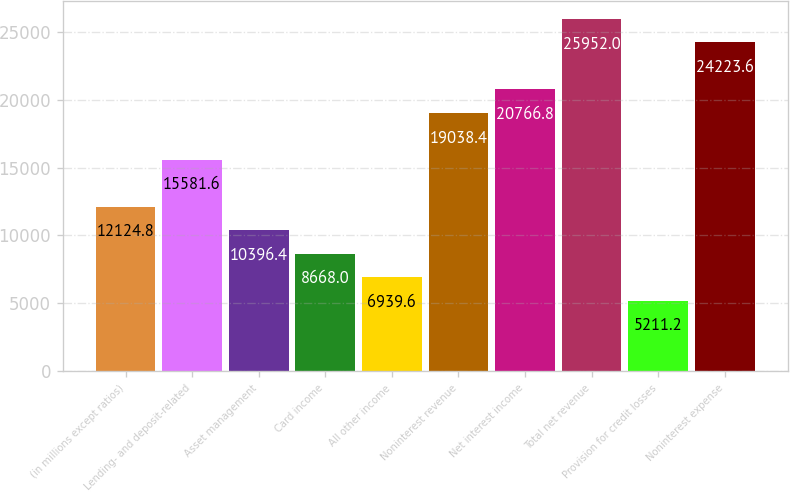Convert chart. <chart><loc_0><loc_0><loc_500><loc_500><bar_chart><fcel>(in millions except ratios)<fcel>Lending- and deposit-related<fcel>Asset management<fcel>Card income<fcel>All other income<fcel>Noninterest revenue<fcel>Net interest income<fcel>Total net revenue<fcel>Provision for credit losses<fcel>Noninterest expense<nl><fcel>12124.8<fcel>15581.6<fcel>10396.4<fcel>8668<fcel>6939.6<fcel>19038.4<fcel>20766.8<fcel>25952<fcel>5211.2<fcel>24223.6<nl></chart> 